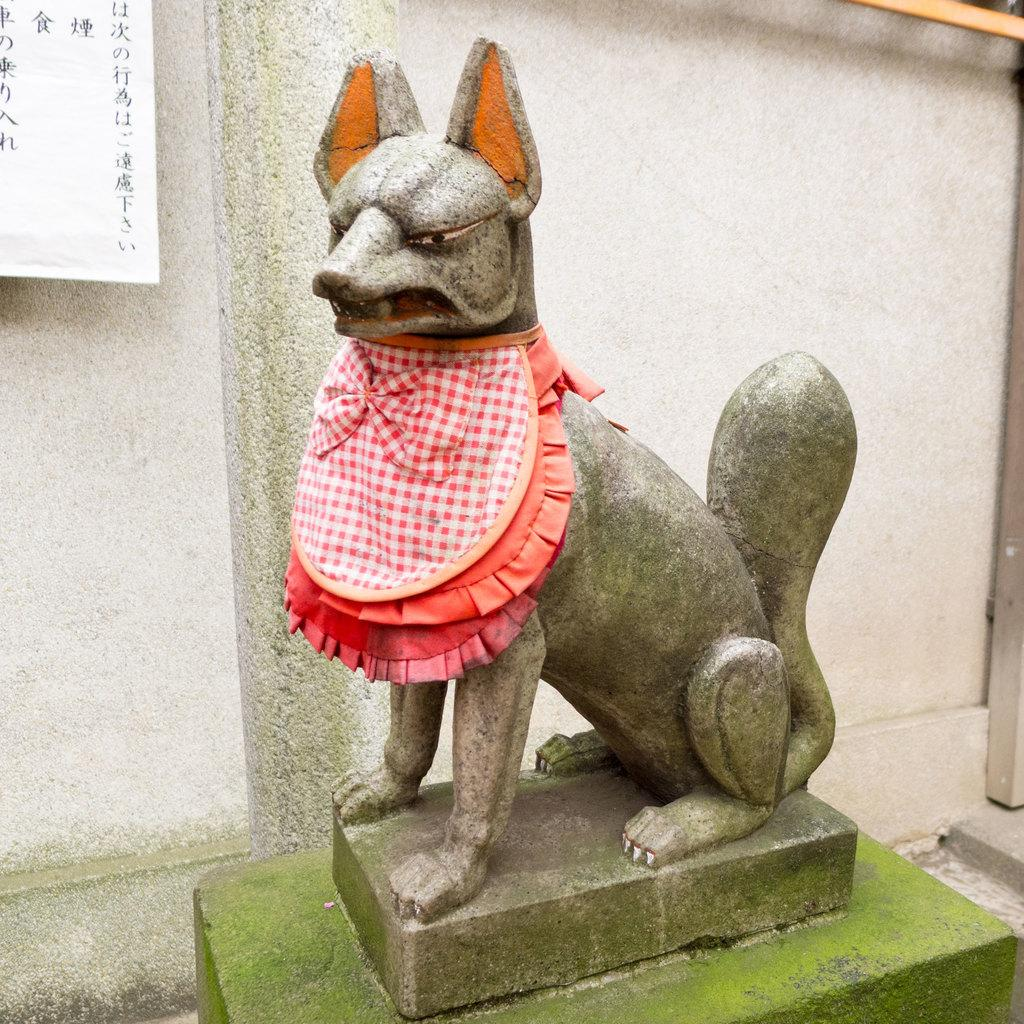What is the main subject of the image? There is a statue of an animal with a dress in the image. What can be seen in the background of the image? There is a paper and a wall in the background of the image. What type of pain can be seen on the animal's face in the image? There is no indication of pain on the animal's face in the image, as it is a statue. What flavor of banana is depicted in the image? There is no banana present in the image. 